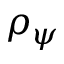<formula> <loc_0><loc_0><loc_500><loc_500>\rho _ { \psi }</formula> 